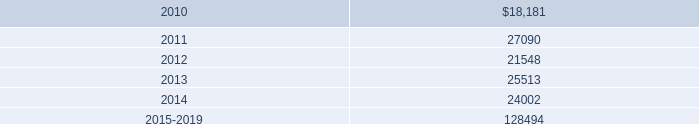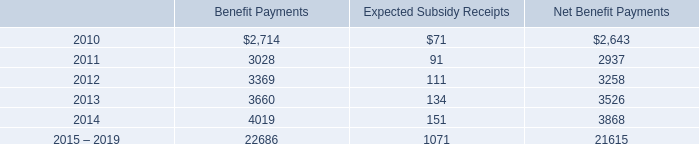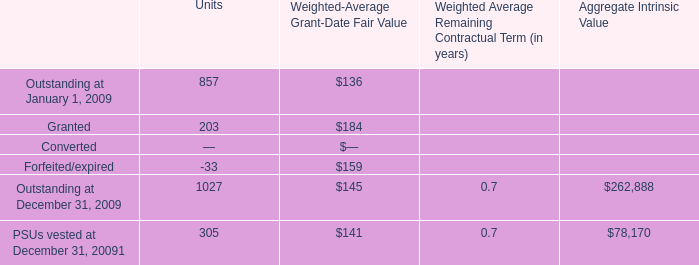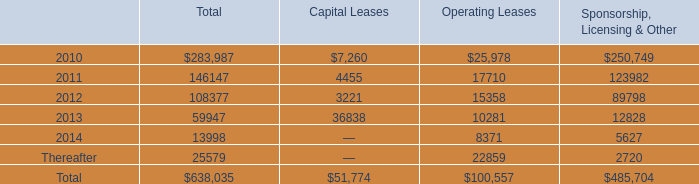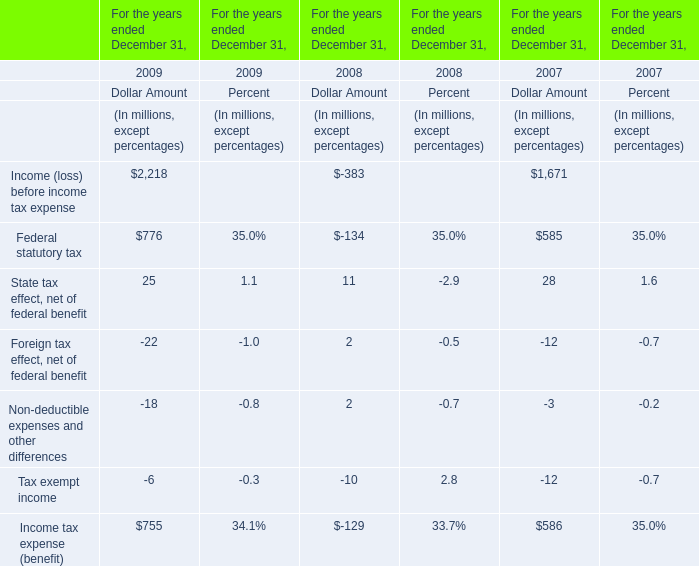what was the average rental expense from 2007 to 2009 
Computations: ((((39586 + 42905) + 35614) + 3) / 2)
Answer: 59054.0. 